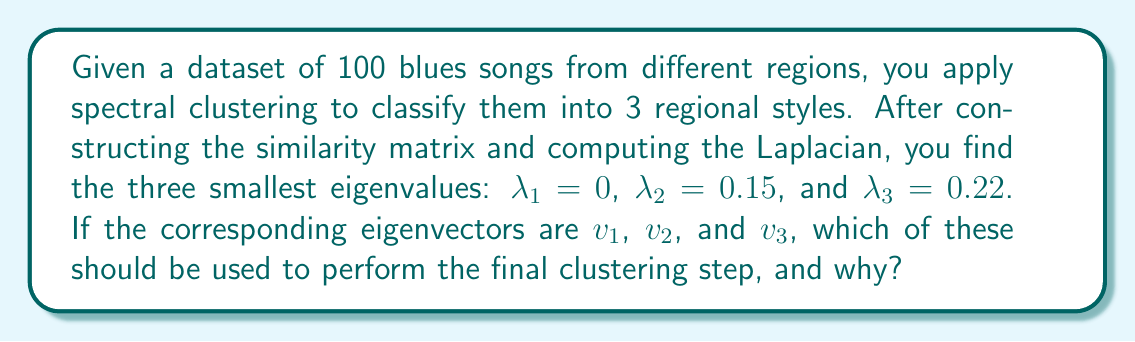Give your solution to this math problem. To understand this problem, let's break it down step-by-step:

1) In spectral clustering, we use the eigenvectors of the Laplacian matrix to perform dimensionality reduction before the final clustering step.

2) The number of clusters we're looking for is 3, which means we need to use the first 3 eigenvectors corresponding to the 3 smallest eigenvalues.

3) However, the first eigenvalue $\lambda_1 = 0$ is always present in the Laplacian spectrum, and its corresponding eigenvector $v_1$ is constant (all elements are the same). This eigenvector doesn't provide any useful information for clustering.

4) The eigenvectors we should use are those corresponding to the next smallest eigenvalues after 0. In this case, that would be $v_2$ and $v_3$, corresponding to $\lambda_2 = 0.15$ and $\lambda_3 = 0.22$.

5) These eigenvectors contain the most important information for separating the data into distinct clusters, representing the different regional styles of blues music.

6) We would use these eigenvectors to form a matrix:

   $$V = [v_2 | v_3]$$

   where each row of $V$ represents a song in the new 2-dimensional space.

7) Finally, we would apply a standard clustering algorithm (like k-means) to this reduced representation to obtain the final clustering into 3 regional styles.
Answer: $v_2$ and $v_3$ 